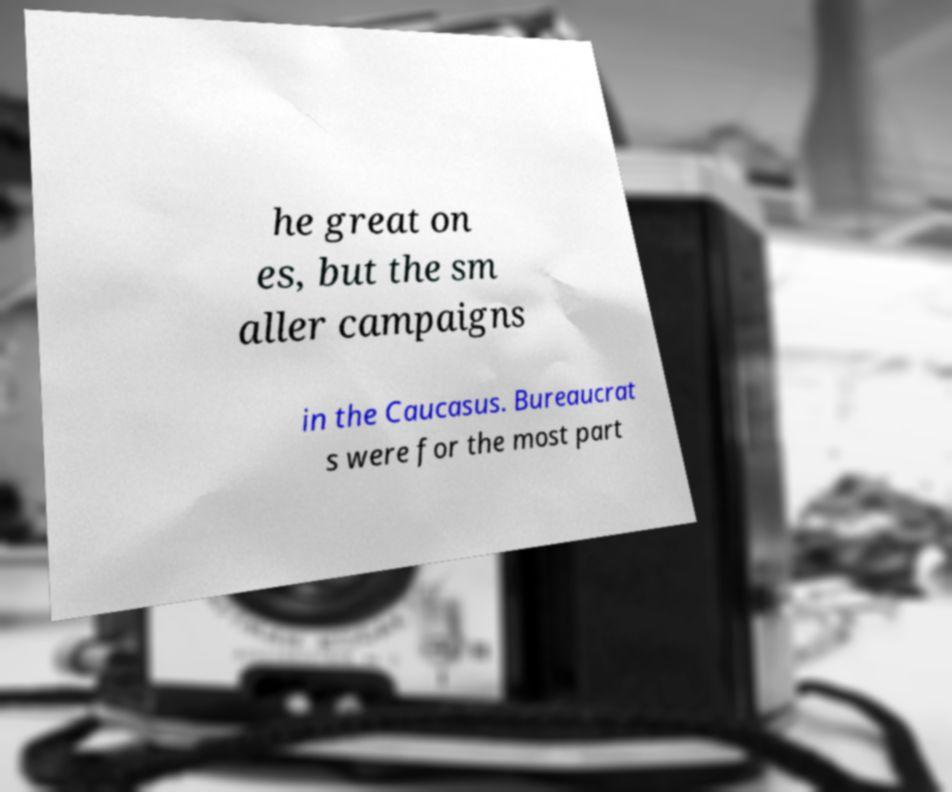I need the written content from this picture converted into text. Can you do that? he great on es, but the sm aller campaigns in the Caucasus. Bureaucrat s were for the most part 